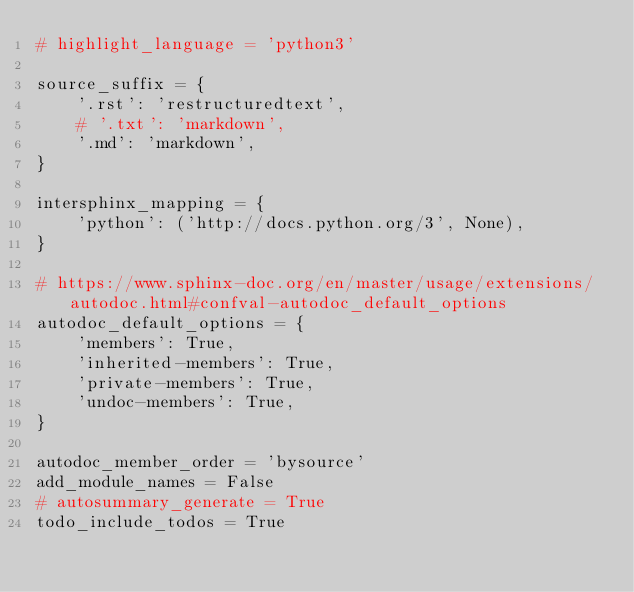Convert code to text. <code><loc_0><loc_0><loc_500><loc_500><_Python_># highlight_language = 'python3'

source_suffix = {
    '.rst': 'restructuredtext',
    # '.txt': 'markdown',
    '.md': 'markdown',
}

intersphinx_mapping = {
    'python': ('http://docs.python.org/3', None),
}

# https://www.sphinx-doc.org/en/master/usage/extensions/autodoc.html#confval-autodoc_default_options
autodoc_default_options = {
    'members': True,
    'inherited-members': True,
    'private-members': True,
    'undoc-members': True,
}

autodoc_member_order = 'bysource'
add_module_names = False
# autosummary_generate = True
todo_include_todos = True
</code> 